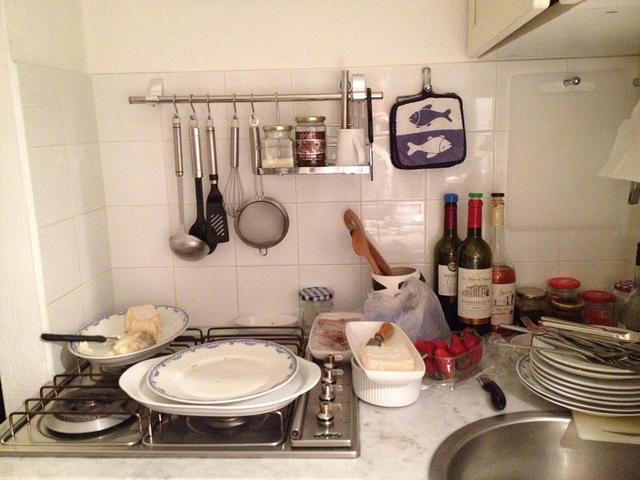How many bottles can you see?
Give a very brief answer. 2. How many bowls can be seen?
Give a very brief answer. 1. How many chairs do you see?
Give a very brief answer. 0. 